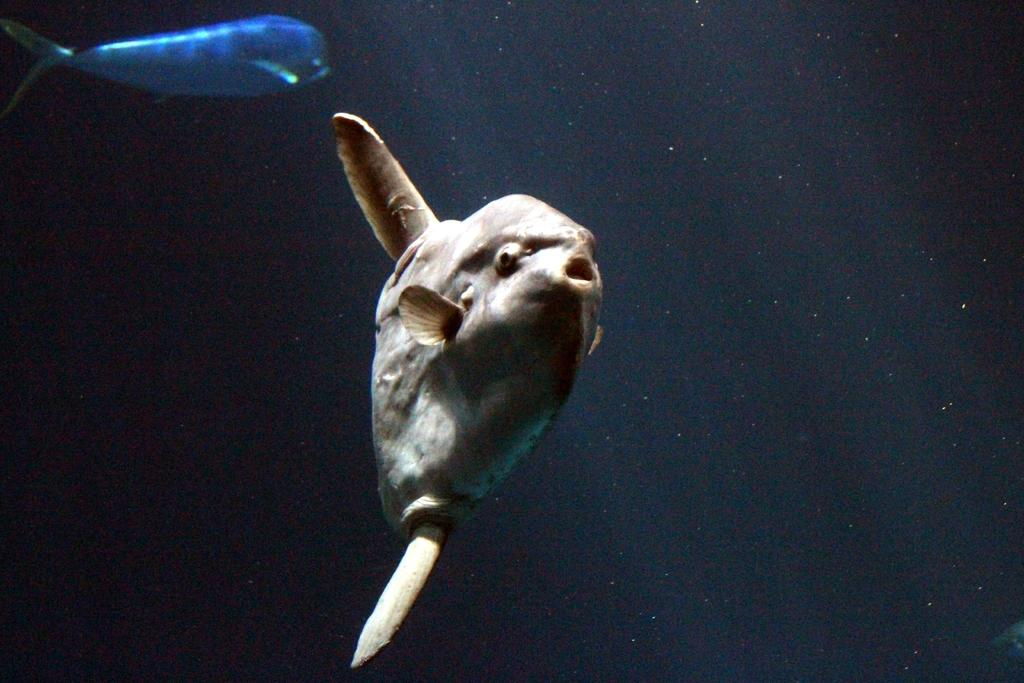What type of animals can be seen in the water in the image? There are fish in the water in the image. What type of harmony does the daughter play in the image? There is no daughter or musical instrument present in the image; it features fish in the water. 